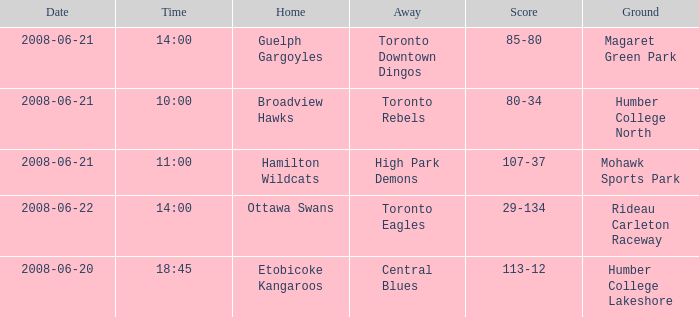What is the Ground with a Date that is 2008-06-20? Humber College Lakeshore. 